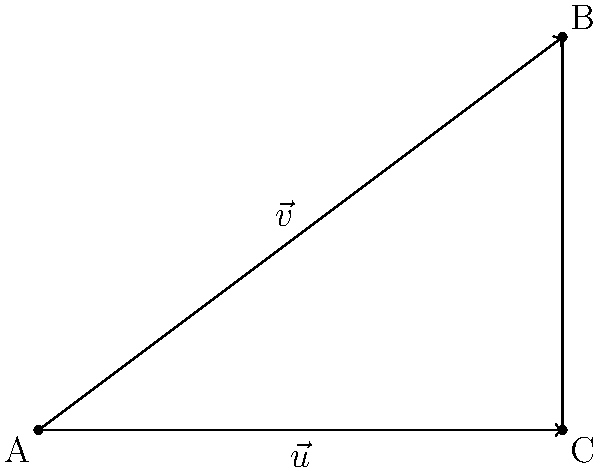In mobile app development, vector projections are often used to optimize interfaces for different screen sizes. Consider a responsive design element represented by vector $\vec{v} = \langle 4, 3 \rangle$. To adjust this element for a wider screen, you need to project $\vec{v}$ onto the horizontal axis represented by $\vec{u} = \langle 4, 0 \rangle$. Calculate the magnitude of the projection of $\vec{v}$ onto $\vec{u}$. To find the magnitude of the projection of $\vec{v}$ onto $\vec{u}$, we'll follow these steps:

1) The formula for vector projection is:
   $$\text{proj}_{\vec{u}} \vec{v} = \frac{\vec{v} \cdot \vec{u}}{\|\vec{u}\|^2} \vec{u}$$

2) Calculate the dot product $\vec{v} \cdot \vec{u}$:
   $$\vec{v} \cdot \vec{u} = 4(4) + 3(0) = 16$$

3) Calculate the magnitude of $\vec{u}$ squared:
   $$\|\vec{u}\|^2 = 4^2 + 0^2 = 16$$

4) Now, we can calculate the scalar projection:
   $$\frac{\vec{v} \cdot \vec{u}}{\|\vec{u}\|^2} = \frac{16}{16} = 1$$

5) The projection vector is:
   $$\text{proj}_{\vec{u}} \vec{v} = 1 \vec{u} = \langle 4, 0 \rangle$$

6) The magnitude of this projection is:
   $$\|\text{proj}_{\vec{u}} \vec{v}\| = \sqrt{4^2 + 0^2} = 4$$

Therefore, the magnitude of the projection of $\vec{v}$ onto $\vec{u}$ is 4.
Answer: 4 